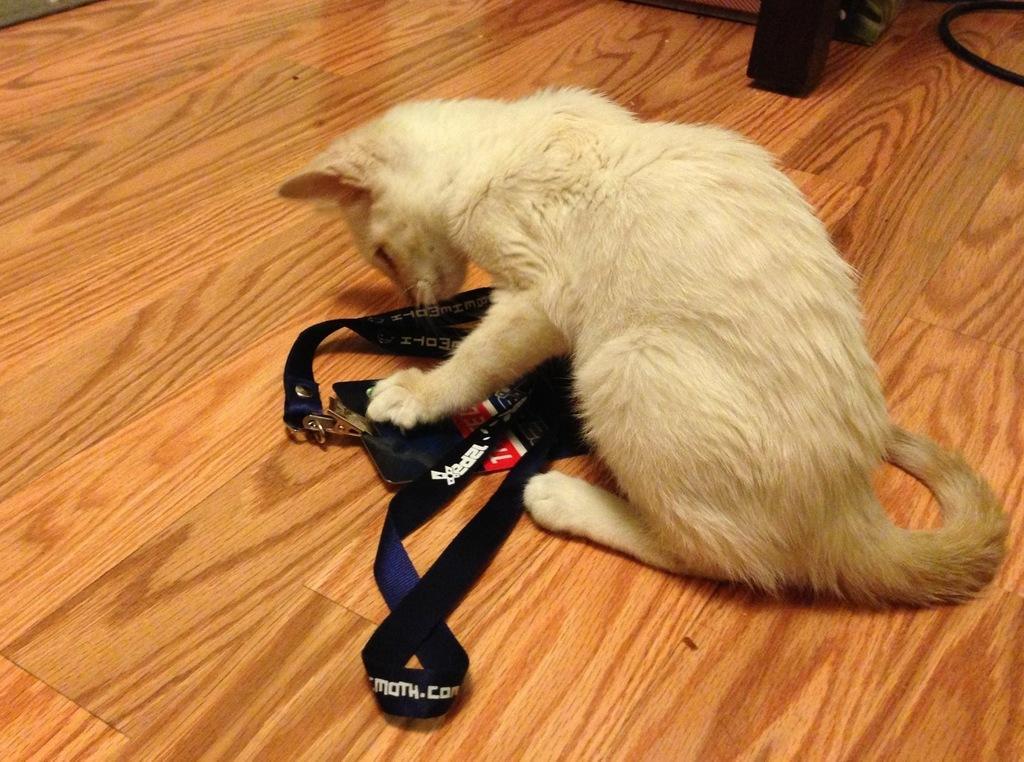Please provide a concise description of this image. In this image I can see a cat holding a strap visible on the wooden floor in the top right I can see a cable and wooden stand. 